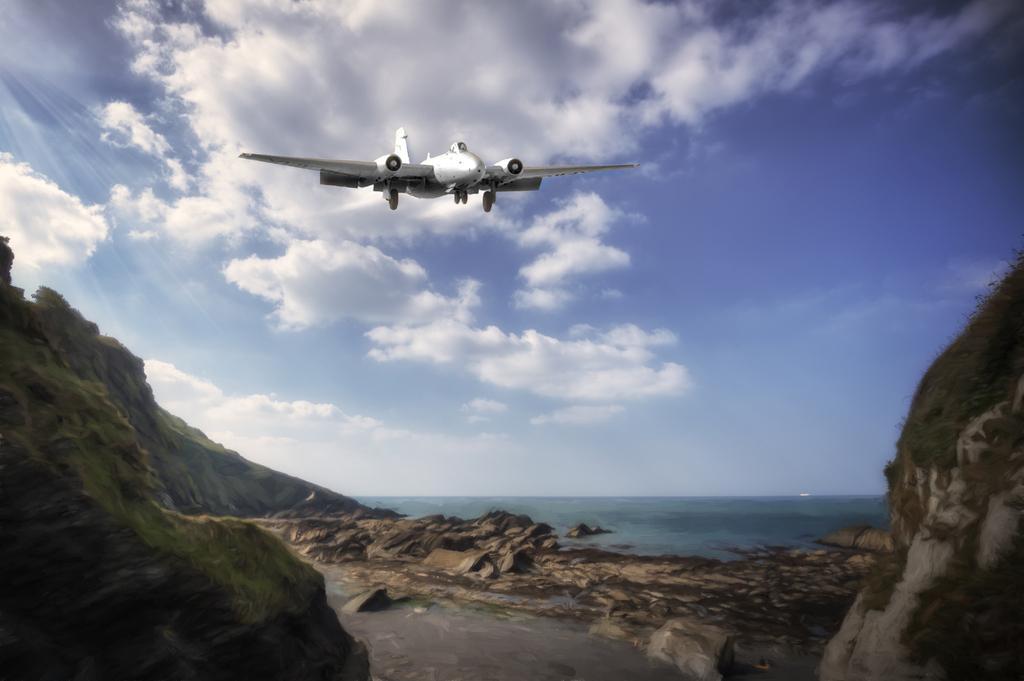Please provide a concise description of this image. In the picture we can see a surface with rock surface hill slopes and behind it we can see the ocean water which is blue in color and in the air we can see an air craft and behind it we can see the sky with clouds. 